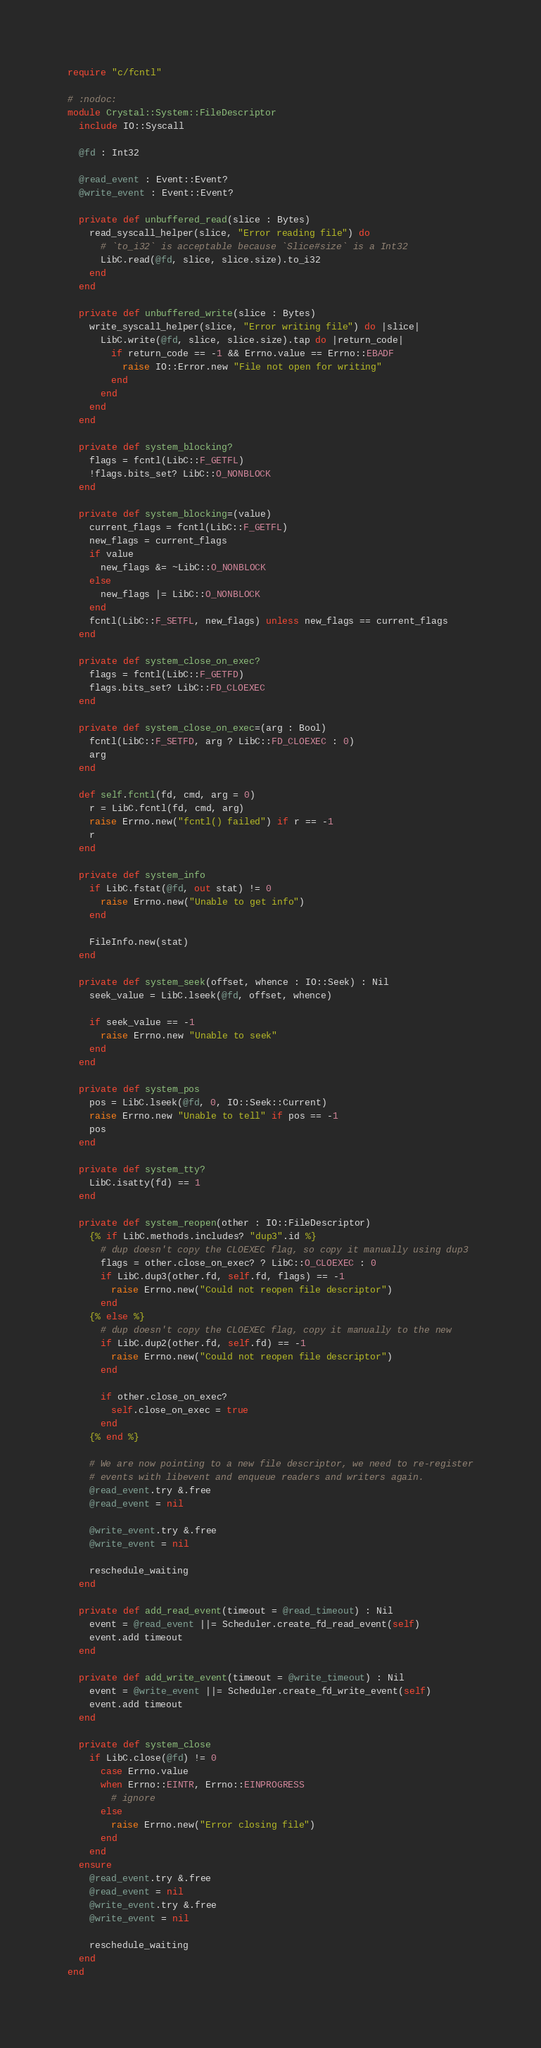<code> <loc_0><loc_0><loc_500><loc_500><_Crystal_>require "c/fcntl"

# :nodoc:
module Crystal::System::FileDescriptor
  include IO::Syscall

  @fd : Int32

  @read_event : Event::Event?
  @write_event : Event::Event?

  private def unbuffered_read(slice : Bytes)
    read_syscall_helper(slice, "Error reading file") do
      # `to_i32` is acceptable because `Slice#size` is a Int32
      LibC.read(@fd, slice, slice.size).to_i32
    end
  end

  private def unbuffered_write(slice : Bytes)
    write_syscall_helper(slice, "Error writing file") do |slice|
      LibC.write(@fd, slice, slice.size).tap do |return_code|
        if return_code == -1 && Errno.value == Errno::EBADF
          raise IO::Error.new "File not open for writing"
        end
      end
    end
  end

  private def system_blocking?
    flags = fcntl(LibC::F_GETFL)
    !flags.bits_set? LibC::O_NONBLOCK
  end

  private def system_blocking=(value)
    current_flags = fcntl(LibC::F_GETFL)
    new_flags = current_flags
    if value
      new_flags &= ~LibC::O_NONBLOCK
    else
      new_flags |= LibC::O_NONBLOCK
    end
    fcntl(LibC::F_SETFL, new_flags) unless new_flags == current_flags
  end

  private def system_close_on_exec?
    flags = fcntl(LibC::F_GETFD)
    flags.bits_set? LibC::FD_CLOEXEC
  end

  private def system_close_on_exec=(arg : Bool)
    fcntl(LibC::F_SETFD, arg ? LibC::FD_CLOEXEC : 0)
    arg
  end

  def self.fcntl(fd, cmd, arg = 0)
    r = LibC.fcntl(fd, cmd, arg)
    raise Errno.new("fcntl() failed") if r == -1
    r
  end

  private def system_info
    if LibC.fstat(@fd, out stat) != 0
      raise Errno.new("Unable to get info")
    end

    FileInfo.new(stat)
  end

  private def system_seek(offset, whence : IO::Seek) : Nil
    seek_value = LibC.lseek(@fd, offset, whence)

    if seek_value == -1
      raise Errno.new "Unable to seek"
    end
  end

  private def system_pos
    pos = LibC.lseek(@fd, 0, IO::Seek::Current)
    raise Errno.new "Unable to tell" if pos == -1
    pos
  end

  private def system_tty?
    LibC.isatty(fd) == 1
  end

  private def system_reopen(other : IO::FileDescriptor)
    {% if LibC.methods.includes? "dup3".id %}
      # dup doesn't copy the CLOEXEC flag, so copy it manually using dup3
      flags = other.close_on_exec? ? LibC::O_CLOEXEC : 0
      if LibC.dup3(other.fd, self.fd, flags) == -1
        raise Errno.new("Could not reopen file descriptor")
      end
    {% else %}
      # dup doesn't copy the CLOEXEC flag, copy it manually to the new
      if LibC.dup2(other.fd, self.fd) == -1
        raise Errno.new("Could not reopen file descriptor")
      end

      if other.close_on_exec?
        self.close_on_exec = true
      end
    {% end %}

    # We are now pointing to a new file descriptor, we need to re-register
    # events with libevent and enqueue readers and writers again.
    @read_event.try &.free
    @read_event = nil

    @write_event.try &.free
    @write_event = nil

    reschedule_waiting
  end

  private def add_read_event(timeout = @read_timeout) : Nil
    event = @read_event ||= Scheduler.create_fd_read_event(self)
    event.add timeout
  end

  private def add_write_event(timeout = @write_timeout) : Nil
    event = @write_event ||= Scheduler.create_fd_write_event(self)
    event.add timeout
  end

  private def system_close
    if LibC.close(@fd) != 0
      case Errno.value
      when Errno::EINTR, Errno::EINPROGRESS
        # ignore
      else
        raise Errno.new("Error closing file")
      end
    end
  ensure
    @read_event.try &.free
    @read_event = nil
    @write_event.try &.free
    @write_event = nil

    reschedule_waiting
  end
end
</code> 